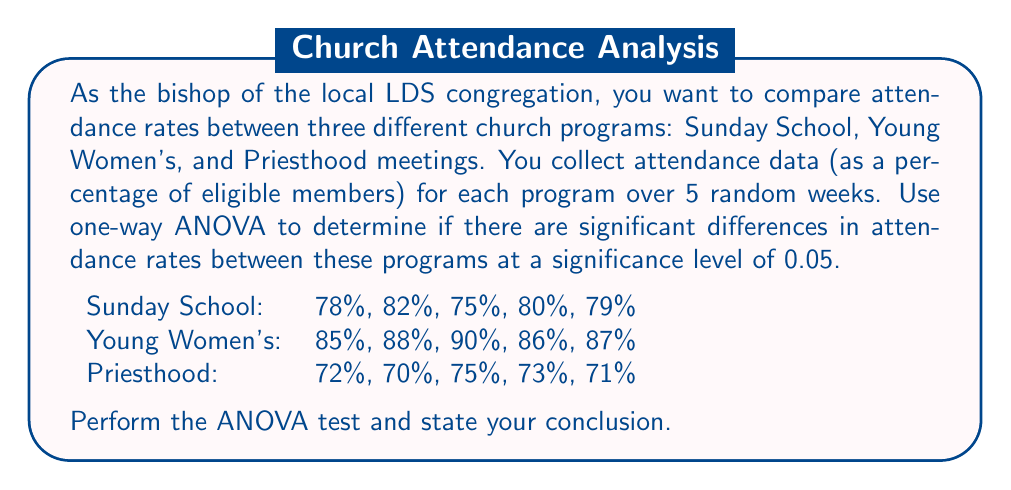Teach me how to tackle this problem. To perform a one-way ANOVA, we'll follow these steps:

1. Calculate the mean for each group and the grand mean:
   Sunday School mean: $\bar{x}_1 = 78.8\%$
   Young Women's mean: $\bar{x}_2 = 87.2\%$
   Priesthood mean: $\bar{x}_3 = 72.2\%$
   Grand mean: $\bar{x} = 79.4\%$

2. Calculate the Sum of Squares Between groups (SSB):
   $$SSB = n\sum_{i=1}^k(\bar{x}_i - \bar{x})^2$$
   where $n$ is the number of observations per group and $k$ is the number of groups.
   $$SSB = 5[(78.8 - 79.4)^2 + (87.2 - 79.4)^2 + (72.2 - 79.4)^2] = 562.8$$

3. Calculate the Sum of Squares Within groups (SSW):
   $$SSW = \sum_{i=1}^k\sum_{j=1}^n(x_{ij} - \bar{x}_i)^2$$
   $$SSW = 26.8 + 14.8 + 14.8 = 56.4$$

4. Calculate the degrees of freedom:
   Between groups: $df_B = k - 1 = 2$
   Within groups: $df_W = N - k = 15 - 3 = 12$
   Total: $df_T = N - 1 = 14$

5. Calculate Mean Square Between (MSB) and Mean Square Within (MSW):
   $$MSB = \frac{SSB}{df_B} = \frac{562.8}{2} = 281.4$$
   $$MSW = \frac{SSW}{df_W} = \frac{56.4}{12} = 4.7$$

6. Calculate the F-statistic:
   $$F = \frac{MSB}{MSW} = \frac{281.4}{4.7} = 59.87$$

7. Find the critical F-value:
   With $df_B = 2$ and $df_W = 12$, and $\alpha = 0.05$, the critical F-value is approximately 3.89.

8. Compare the F-statistic to the critical F-value:
   Since $59.87 > 3.89$, we reject the null hypothesis.

Conclusion: There is strong evidence to suggest that there are significant differences in attendance rates between the three church programs (F(2, 12) = 59.87, p < 0.05).
Answer: Reject the null hypothesis. There are significant differences in attendance rates between Sunday School, Young Women's, and Priesthood meetings (F(2, 12) = 59.87, p < 0.05). 